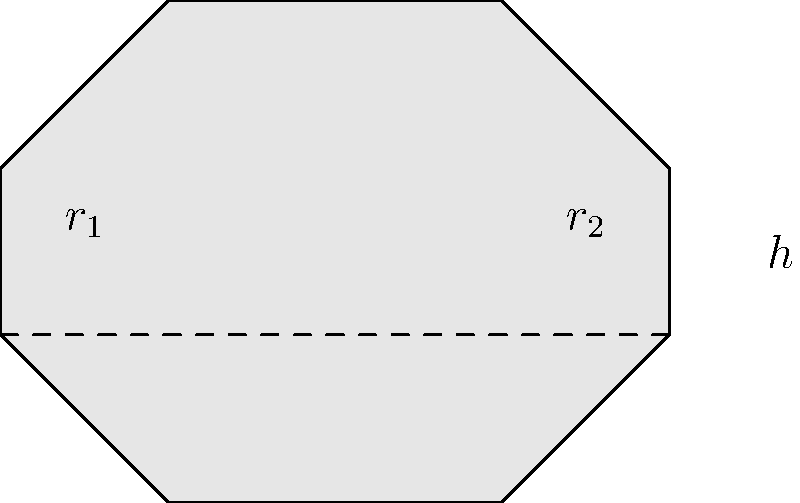As an ex-weightlifter, you're designing a custom dumbbell for your home gym. The dumbbell's shape can be approximated by two spherical ends connected by a cylindrical bar. If the radius of each spherical end ($r_1$) is 5 cm, the radius of the cylindrical bar ($r_2$) is 2 cm, and the length of the bar (h) is 15 cm, what is the total volume of the dumbbell in cubic centimeters? To calculate the volume of the dumbbell, we need to add the volumes of its components:

1. Volume of two spherical ends:
   $$V_{spheres} = 2 \cdot \frac{4}{3}\pi r_1^3$$
   $$V_{spheres} = 2 \cdot \frac{4}{3}\pi (5\text{ cm})^3 = \frac{1000\pi}{3} \text{ cm}^3$$

2. Volume of the cylindrical bar:
   $$V_{cylinder} = \pi r_2^2 h$$
   $$V_{cylinder} = \pi (2\text{ cm})^2 (15\text{ cm}) = 60\pi \text{ cm}^3$$

3. Total volume:
   $$V_{total} = V_{spheres} + V_{cylinder}$$
   $$V_{total} = \frac{1000\pi}{3} \text{ cm}^3 + 60\pi \text{ cm}^3$$
   $$V_{total} = \frac{1000\pi + 180\pi}{3} \text{ cm}^3 = \frac{1180\pi}{3} \text{ cm}^3$$

4. Simplifying and rounding to the nearest cubic centimeter:
   $$V_{total} \approx 1236 \text{ cm}^3$$
Answer: 1236 cm³ 